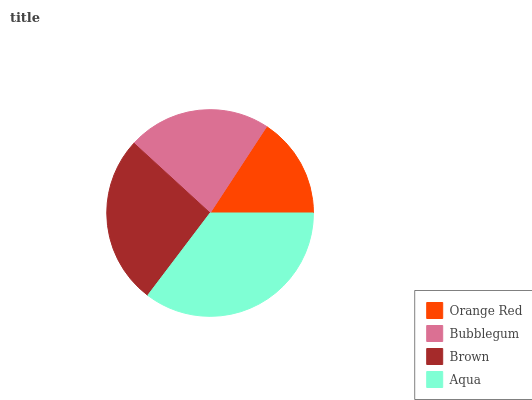Is Orange Red the minimum?
Answer yes or no. Yes. Is Aqua the maximum?
Answer yes or no. Yes. Is Bubblegum the minimum?
Answer yes or no. No. Is Bubblegum the maximum?
Answer yes or no. No. Is Bubblegum greater than Orange Red?
Answer yes or no. Yes. Is Orange Red less than Bubblegum?
Answer yes or no. Yes. Is Orange Red greater than Bubblegum?
Answer yes or no. No. Is Bubblegum less than Orange Red?
Answer yes or no. No. Is Brown the high median?
Answer yes or no. Yes. Is Bubblegum the low median?
Answer yes or no. Yes. Is Aqua the high median?
Answer yes or no. No. Is Brown the low median?
Answer yes or no. No. 